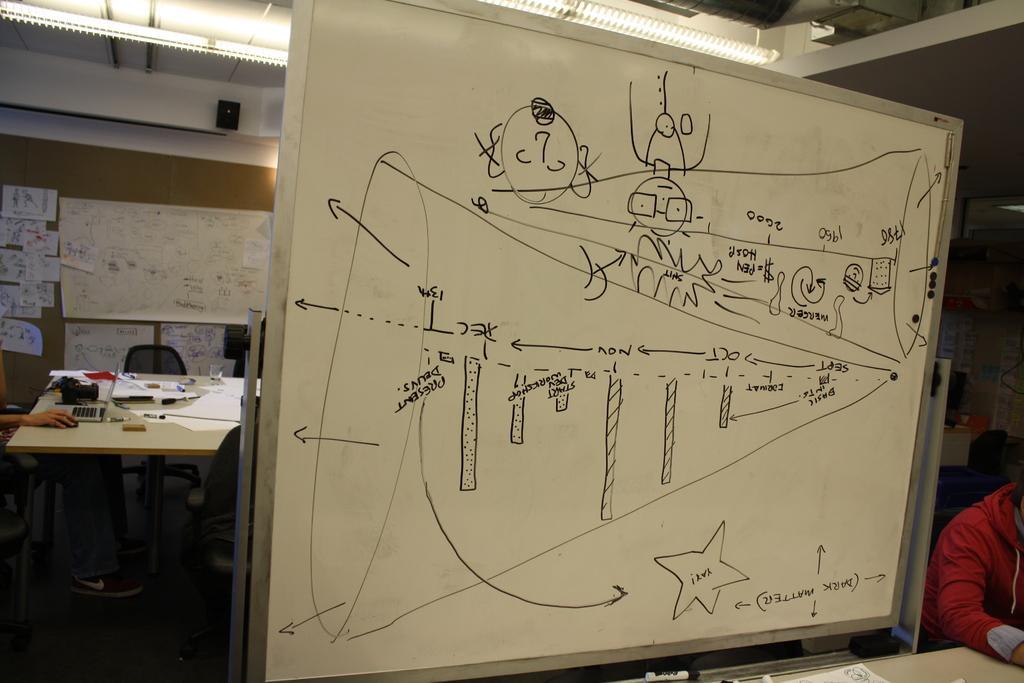Describe this image in one or two sentences. In this image I can see a person is sitting on the chair. On the table there is a paper,laptop,mouse and a marker. In front there is aboard on the board some thing is written with the black marker. At the back side there is a chart paper on the board. At the back side the wall is in white color. On the right side the person is wearing a red jacket. 